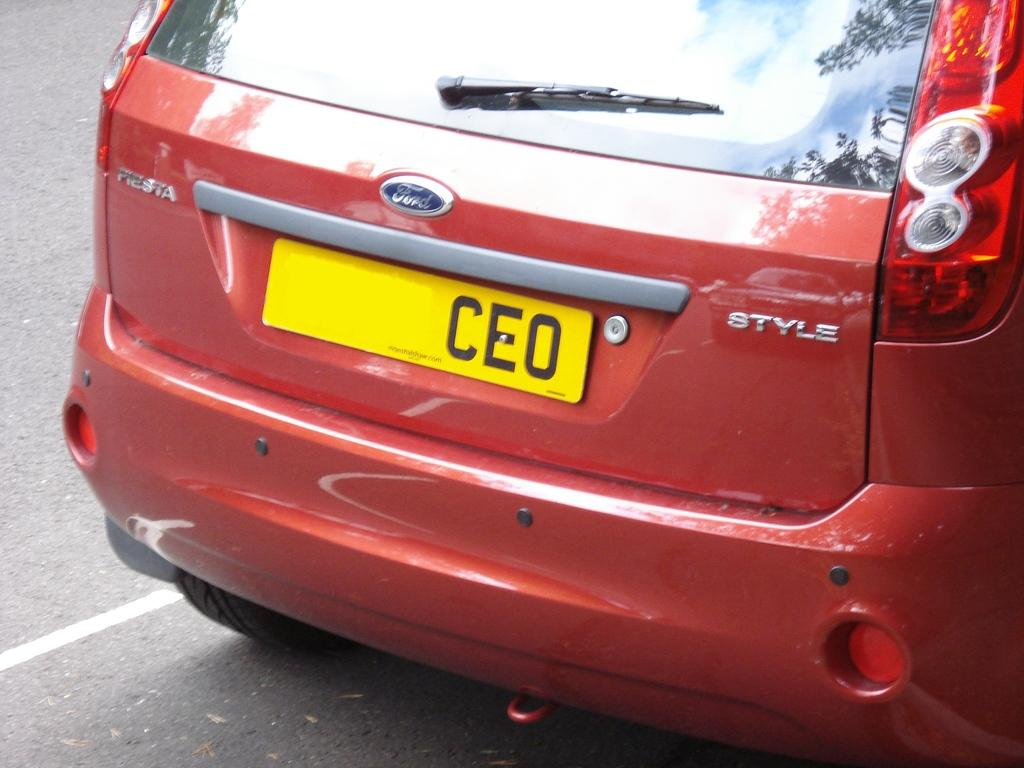<image>
Write a terse but informative summary of the picture. A red Fiesta with a yellow license plate that says CEO. 